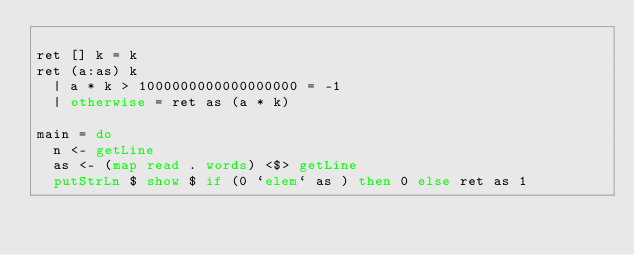Convert code to text. <code><loc_0><loc_0><loc_500><loc_500><_Haskell_>
ret [] k = k
ret (a:as) k 
  | a * k > 1000000000000000000 = -1
  | otherwise = ret as (a * k)

main = do
  n <- getLine
  as <- (map read . words) <$> getLine
  putStrLn $ show $ if (0 `elem` as ) then 0 else ret as 1
</code> 